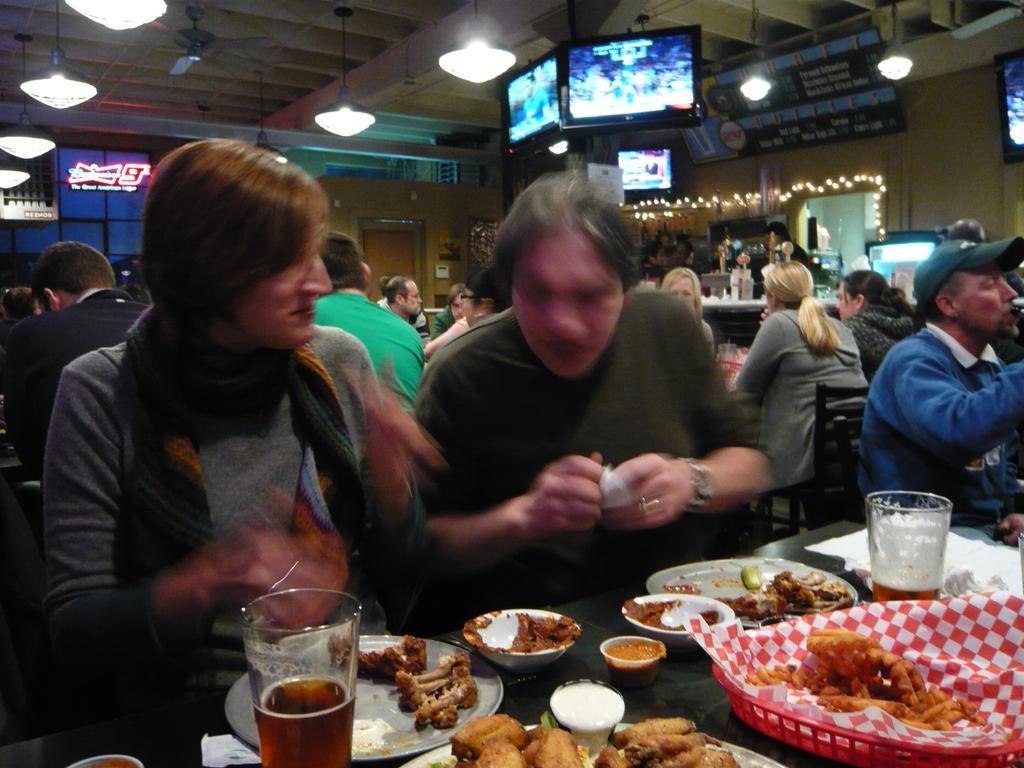How would you summarize this image in a sentence or two? In this image we can see people sitting on the chairs and tables are placed in front of them. On the tables we can see serving plates with food in them, glass tumblers with beverage in them and sauce bowls. In the background we can see display screens, electric lights hanging from the top and decor lights. 